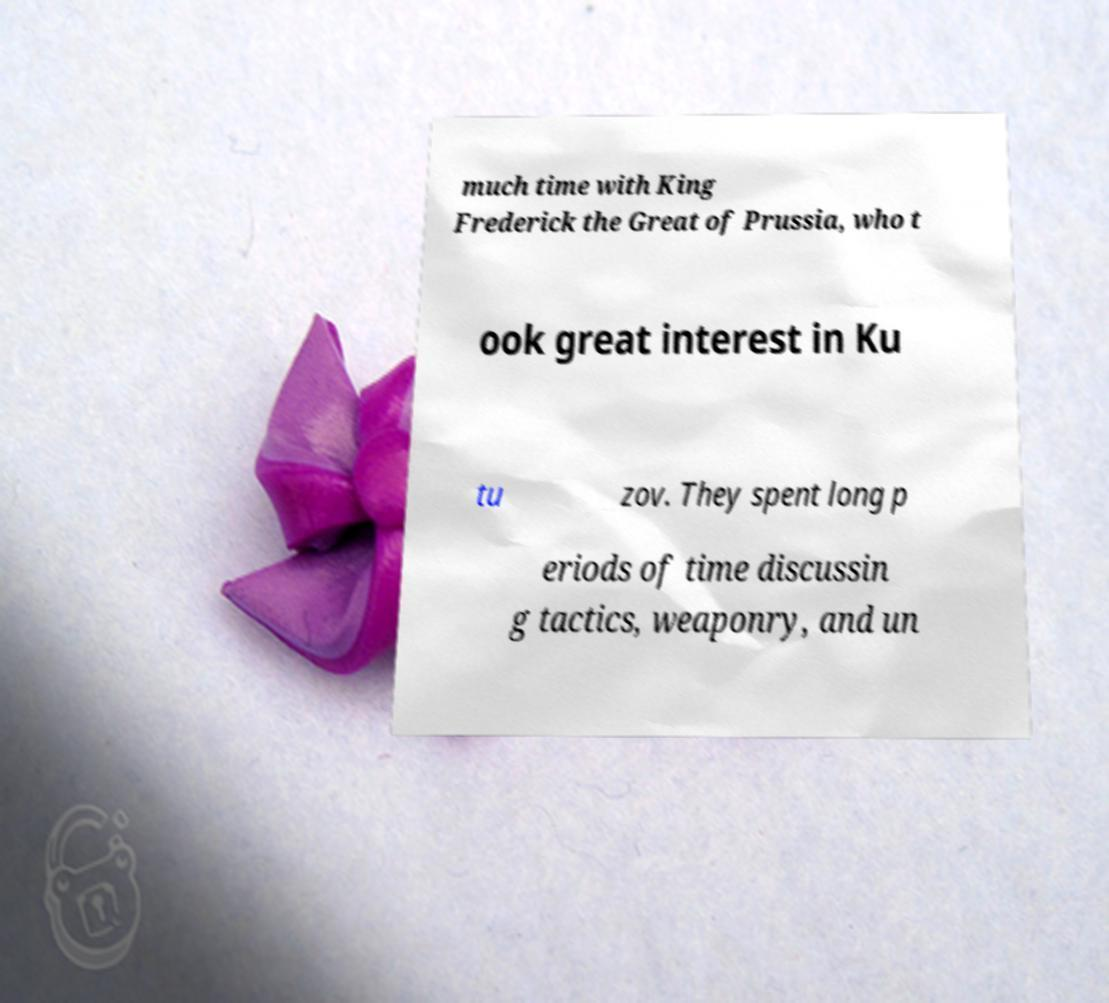Can you accurately transcribe the text from the provided image for me? much time with King Frederick the Great of Prussia, who t ook great interest in Ku tu zov. They spent long p eriods of time discussin g tactics, weaponry, and un 